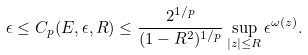<formula> <loc_0><loc_0><loc_500><loc_500>\epsilon \leq C _ { p } ( E , \epsilon , R ) \leq \frac { 2 ^ { 1 / p } } { ( 1 - R ^ { 2 } ) ^ { 1 / p } } \sup _ { | z | \leq R } \epsilon ^ { \omega ( z ) } .</formula> 